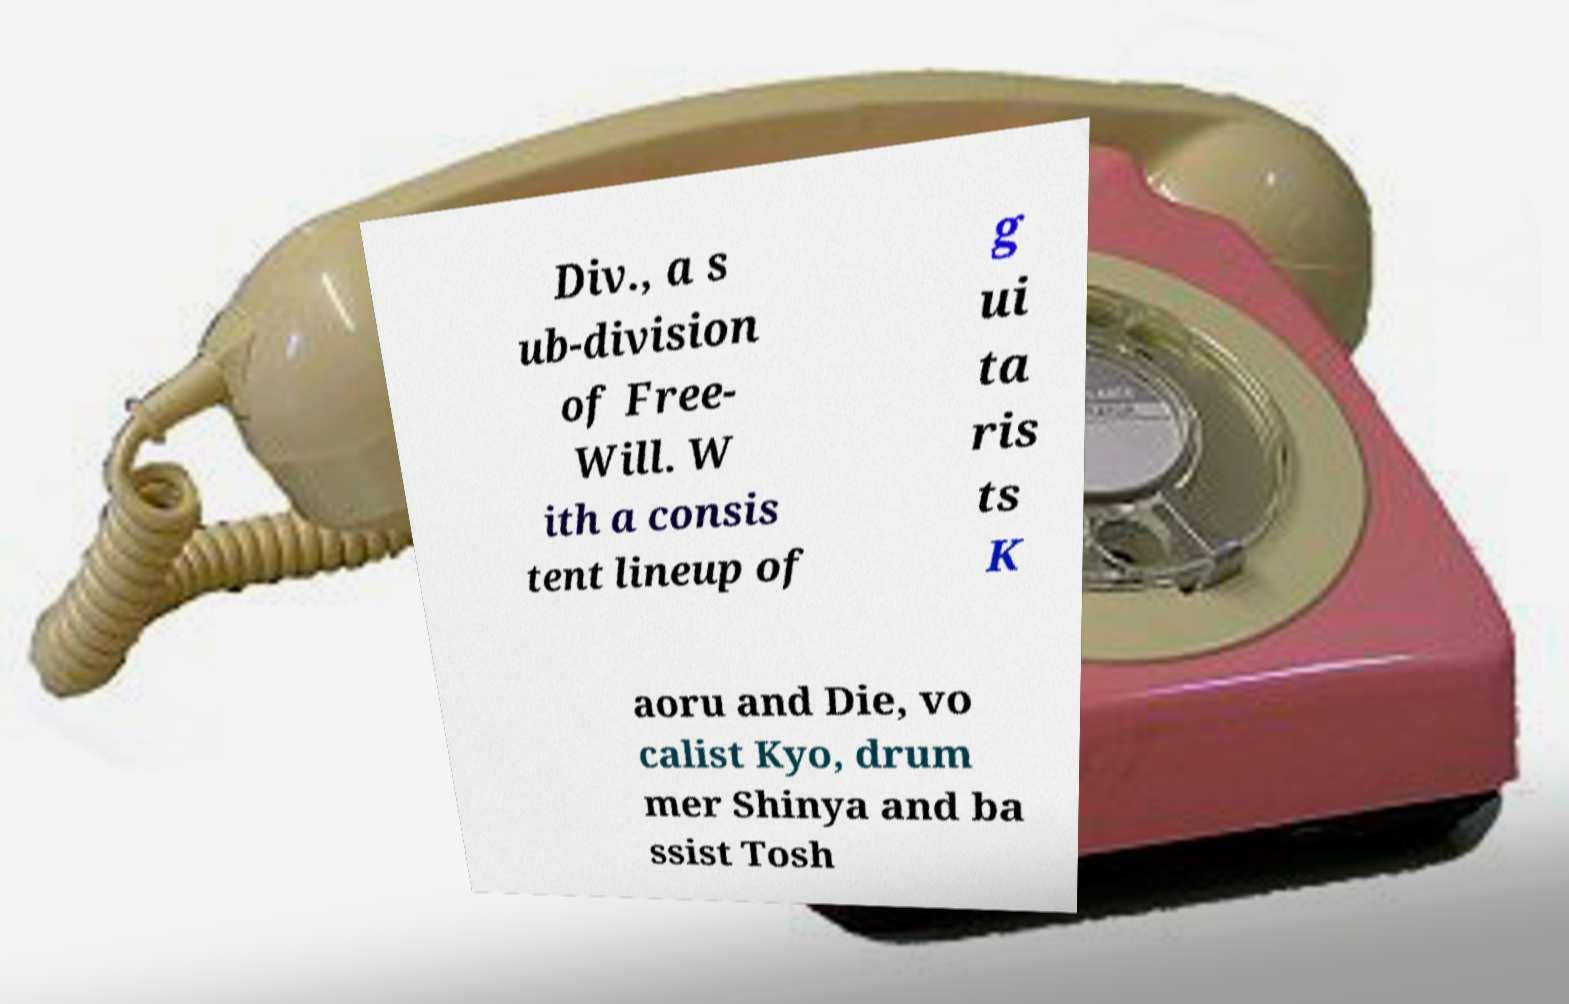Please read and relay the text visible in this image. What does it say? Div., a s ub-division of Free- Will. W ith a consis tent lineup of g ui ta ris ts K aoru and Die, vo calist Kyo, drum mer Shinya and ba ssist Tosh 